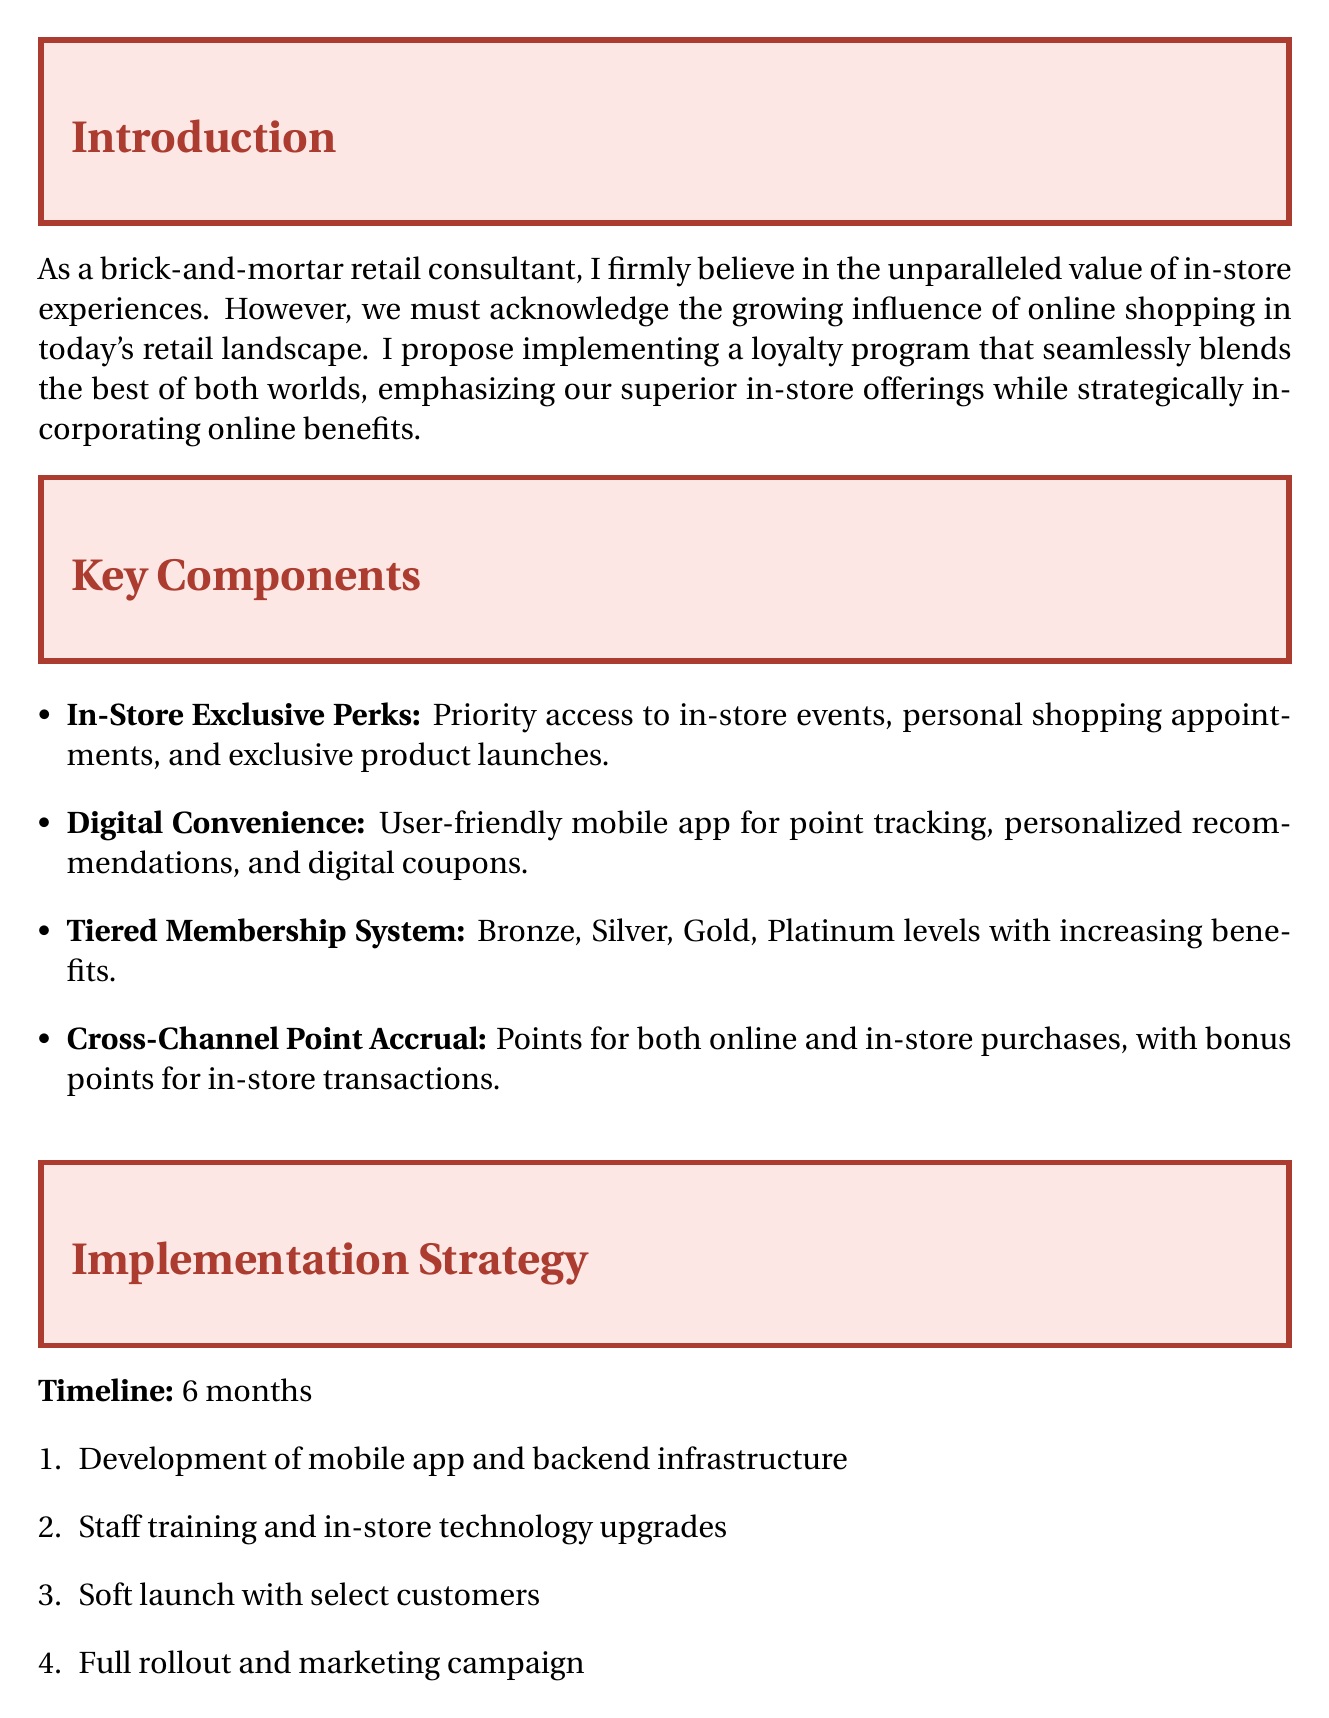What is the title of the memo? The title of the memo is prominently displayed at the top, which is "Enhancing Customer Loyalty: A Hybrid Approach for Brick-and-Mortar Excellence."
Answer: Enhancing Customer Loyalty: A Hybrid Approach for Brick-and-Mortar Excellence What are the tiers in the membership system? The tiers in the membership system are listed in the key components section, which includes Bronze, Silver, Gold, and Platinum.
Answer: Bronze, Silver, Gold, Platinum How long is the proposed implementation timeline? The timeline for implementation is specified in the implementation strategy section as 6 months.
Answer: 6 months Which company is associated with the "Beauty Insider" loyalty program? The case studies section mentions Sephora as the company with the "Beauty Insider" program.
Answer: Sephora What is the expected outcome regarding foot traffic? One of the expected outcomes listed is "Increased foot traffic to physical stores."
Answer: Increased foot traffic to physical stores What type of mobile application is introduced as part of the proposal? The document states that a user-friendly mobile app is introduced for point tracking and other features.
Answer: User-friendly mobile app What is the main purpose of implementing the loyalty program? The conclusion summarizes the purpose of the program as strengthening customer relationships and driving foot traffic.
Answer: Strengthening customer relationships, driving foot traffic What phase involves staff training? The implementation strategy specifies that staff training occurs in Phase 2 of the proposed plan.
Answer: Phase 2 What is a major success factor for the Nordstrom loyalty program? The document includes that the success factor for Nordstrom's loyalty program is its "Seamless integration of online and offline experiences."
Answer: Seamless integration of online and offline experiences 